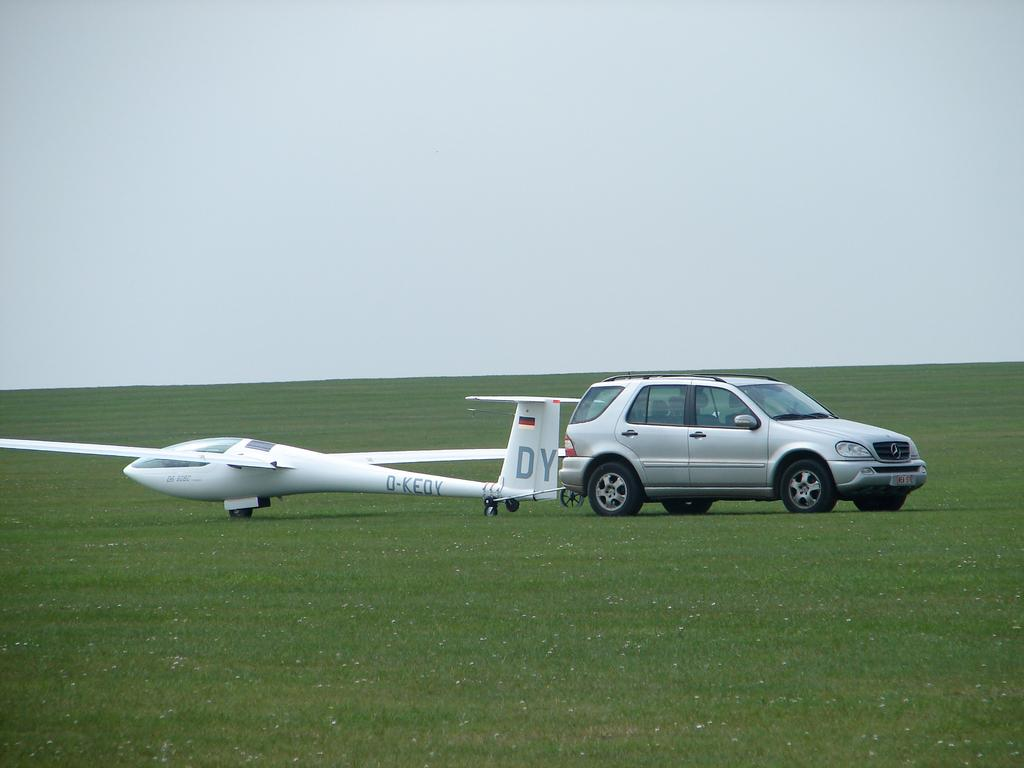<image>
Render a clear and concise summary of the photo. Gray suv sits in a field with an airplane with D-Kedy on the wing 